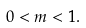Convert formula to latex. <formula><loc_0><loc_0><loc_500><loc_500>0 < m < 1 .</formula> 